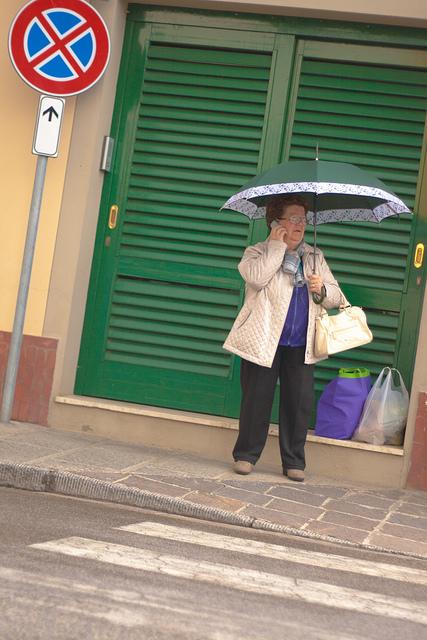Is this woman holding an umbrella?
Give a very brief answer. Yes. What color is the umbrella?
Concise answer only. Green. What color is the round sign?
Be succinct. Red and blue. 